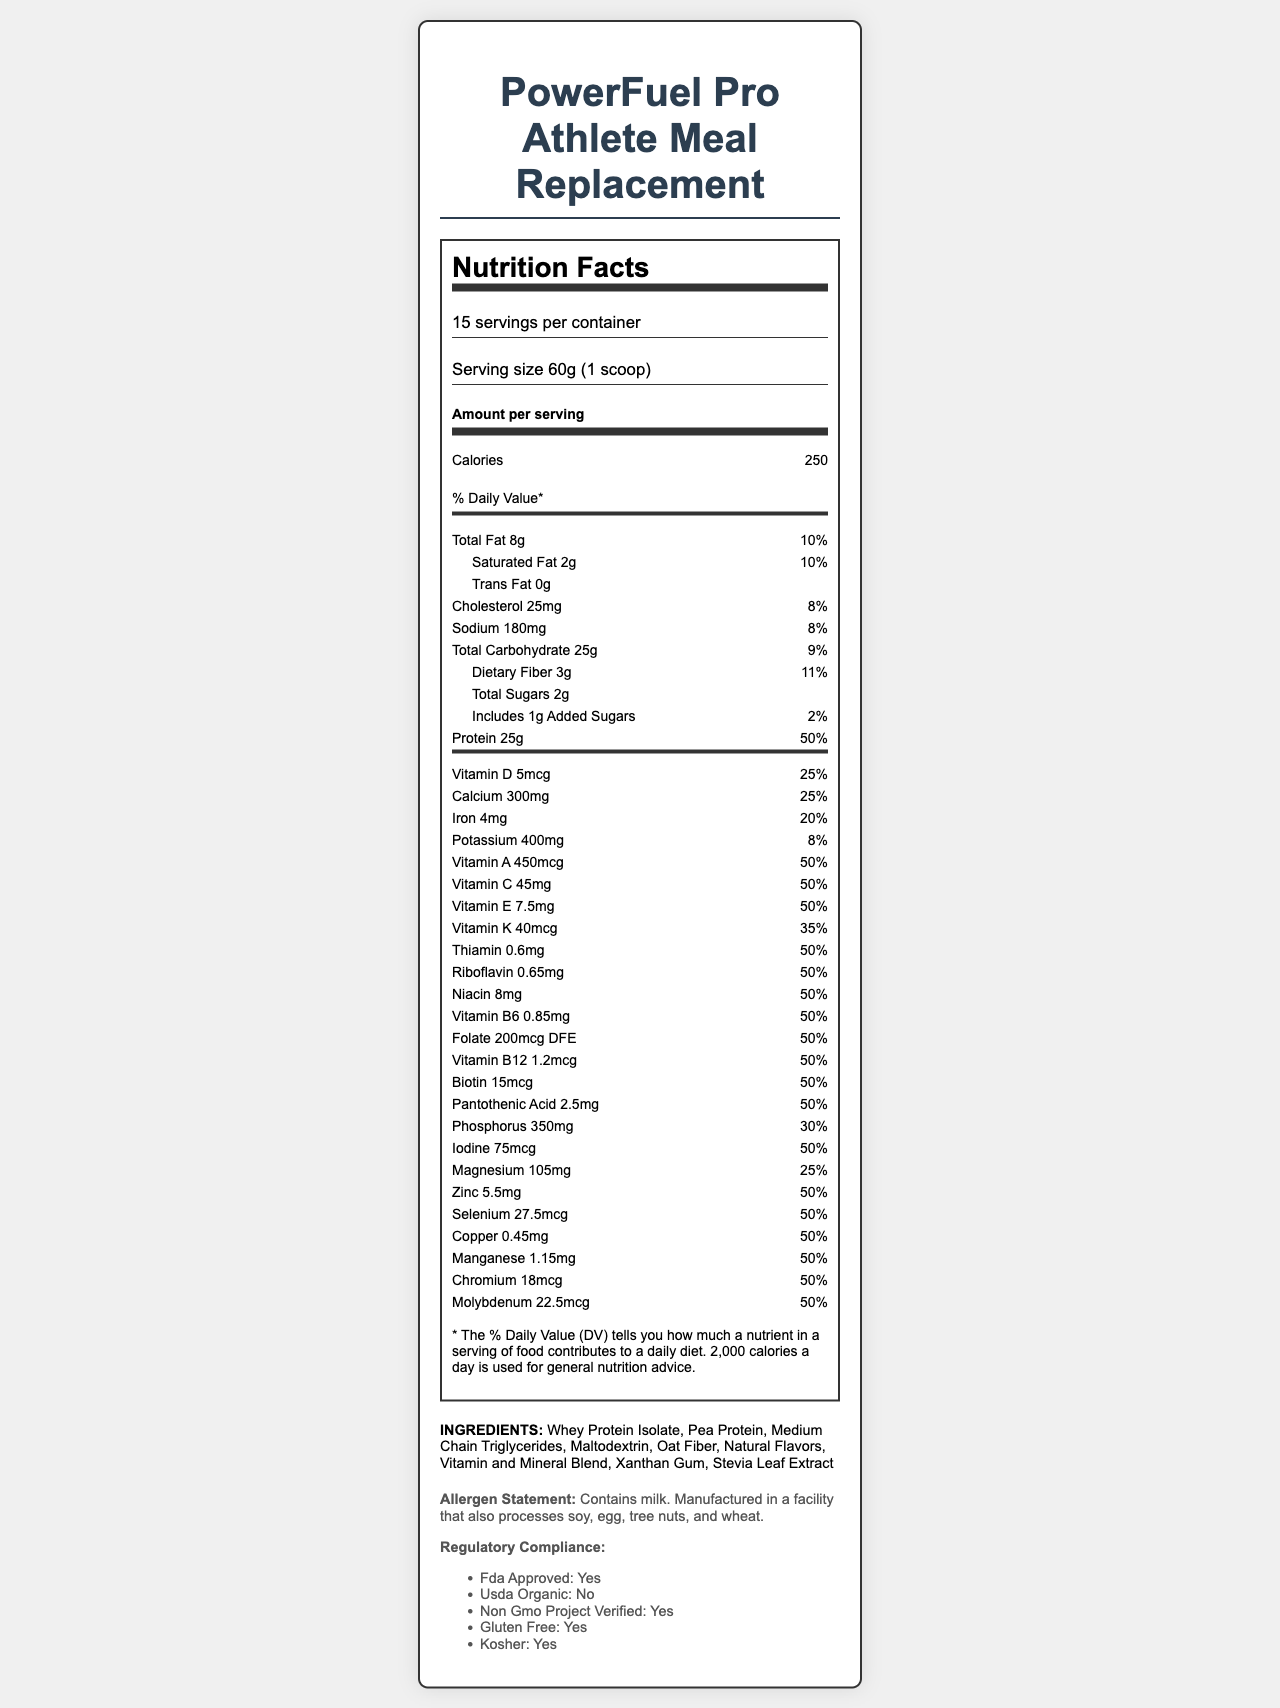What is the serving size of the product? The serving size is provided under the "Serving size" label as 60g, which is equivalent to 1 scoop.
Answer: 60g (1 scoop) How many servings are there per container? The document states "15 servings per container" under the serving information.
Answer: 15 How many calories are there per serving? The calories per serving are listed as 250 in the "Amount per serving" section.
Answer: 250 What is the total fat content per serving? The total fat content is specified as 8g under the "Total Fat" nutrient.
Answer: 8g What percentage of the daily value does the protein in this product contribute? The document states that the protein content contributes 50% to the daily value.
Answer: 50% What are the macronutrient ratios for this product?  A. 30% protein, 50% carbohydrates, 20% fats B. 40% protein, 40% carbohydrates, 20% fats C. 40% protein, 30% carbohydrates, 30% fats The macronutrient ratios are listed as 40% protein, 40% carbohydrates, and 20% fats.
Answer: B What is the total amount of carbohydrates per serving? A. 20g B. 25g C. 30g D. 35g The document lists the total carbohydrates as 25g per serving.
Answer: B Is the product gluten-free? The document mentions under "Regulatory Compliance" that the product is gluten-free.
Answer: Yes Does the product contain any allergens? The allergen statement specifies that the product contains milk and is manufactured in a facility that processes soy, egg, tree nuts, and wheat.
Answer: Yes Summarize the main idea of the document. The document focuses on presenting the nutritional content and compliance details of a meal replacement product meant for athletes, detailing macronutrients, vitamins, minerals, ingredients, and certifications.
Answer: The document provides the Nutrition Facts Label for PowerFuel Pro Athlete Meal Replacement, including detailed nutrition information, ingredient list, allergen statement, macronutrient ratios, regulatory compliance, and quality control features. What is the amount of vitamin D per serving? The vitamin D content is listed as 5mcg in the vitamins and minerals section.
Answer: 5mcg What is the daily value percentage for calcium in this product? The daily value percentage for calcium is stated as 25%.
Answer: 25% Is the product approved by the FDA? The document specifies under "Regulatory Compliance" that the product is FDA approved.
Answer: Yes What ingredients are used in this product? The ingredients are listed in a comma-separated format under the "INGREDIENTS" section.
Answer: Whey Protein Isolate, Pea Protein, Medium Chain Triglycerides, Maltodextrin, Oat Fiber, Natural Flavors, Vitamin and Mineral Blend, Xanthan Gum, Stevia Leaf Extract What is the import duty rate for this product? The document mentions that the import duties for this product are 5% ad valorem under the "tax considerations" section.
Answer: 5% ad valorem Is there enough information to determine the manufacturing country of this product? The document does not provide any details about the manufacturing country, thus this information cannot be determined from the provided content.
Answer: Not enough information How much cholesterol is in each serving? The cholesterol amount is listed as 25mg in the nutrient details section.
Answer: 25mg What percentage of the daily value does the dietary fiber in this product contribute? The daily value contribution of dietary fiber is listed as 11% in the total carbohydrate section.
Answer: 11% 